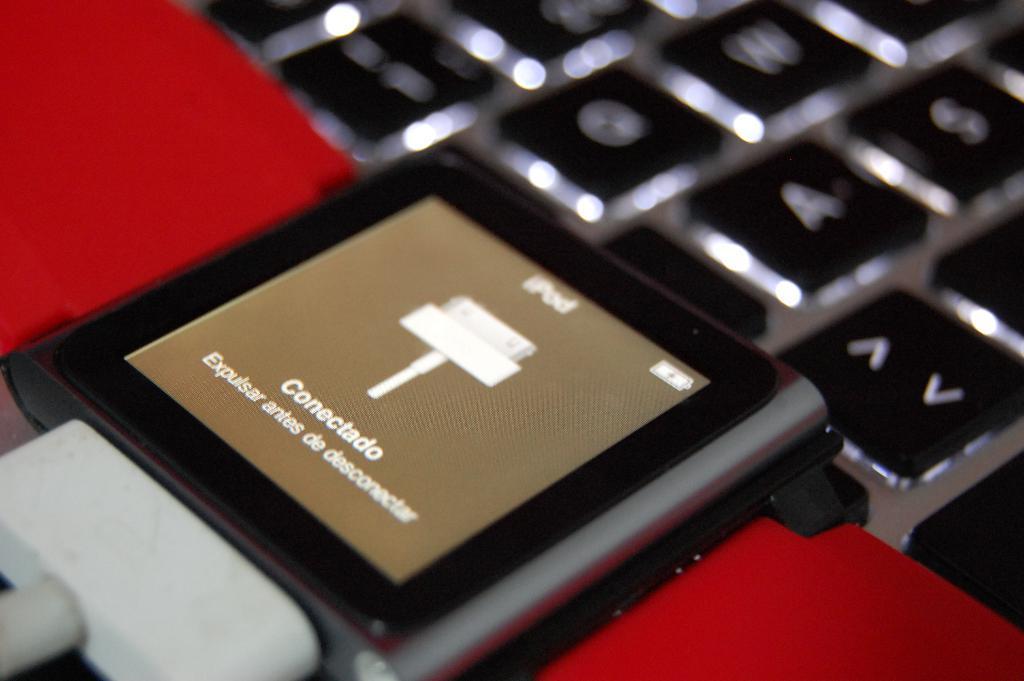How would you summarize this image in a sentence or two? In this image there is one white colored charger is connected to ipod at bottom of this image and there is one keyboard at top of this image. 